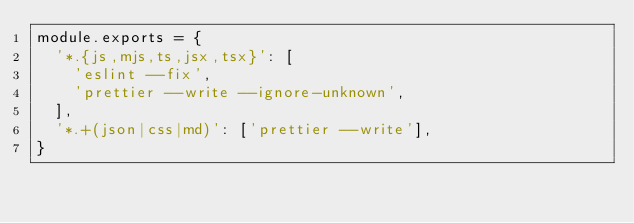Convert code to text. <code><loc_0><loc_0><loc_500><loc_500><_JavaScript_>module.exports = {
  '*.{js,mjs,ts,jsx,tsx}': [
    'eslint --fix',
    'prettier --write --ignore-unknown',
  ],
  '*.+(json|css|md)': ['prettier --write'],
}
</code> 